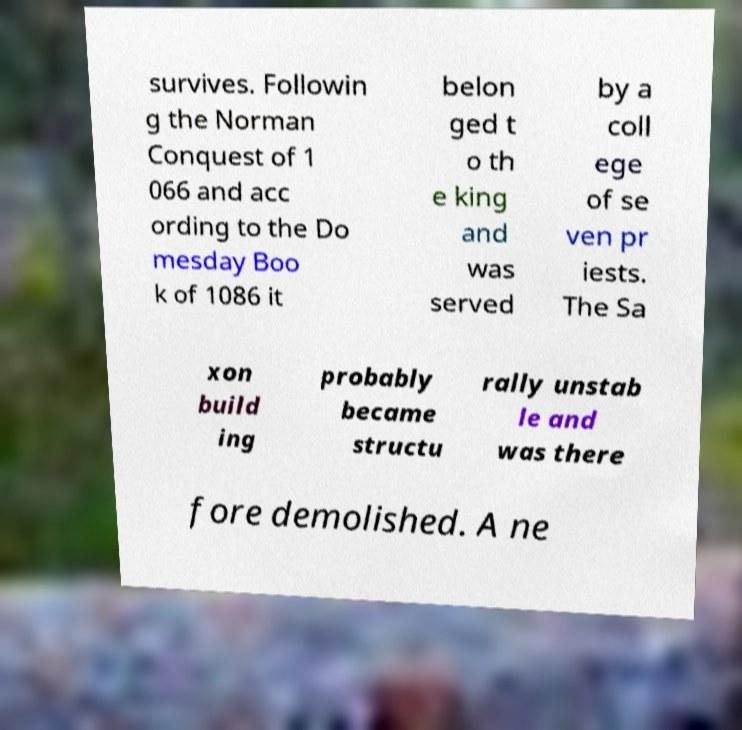Can you read and provide the text displayed in the image?This photo seems to have some interesting text. Can you extract and type it out for me? survives. Followin g the Norman Conquest of 1 066 and acc ording to the Do mesday Boo k of 1086 it belon ged t o th e king and was served by a coll ege of se ven pr iests. The Sa xon build ing probably became structu rally unstab le and was there fore demolished. A ne 